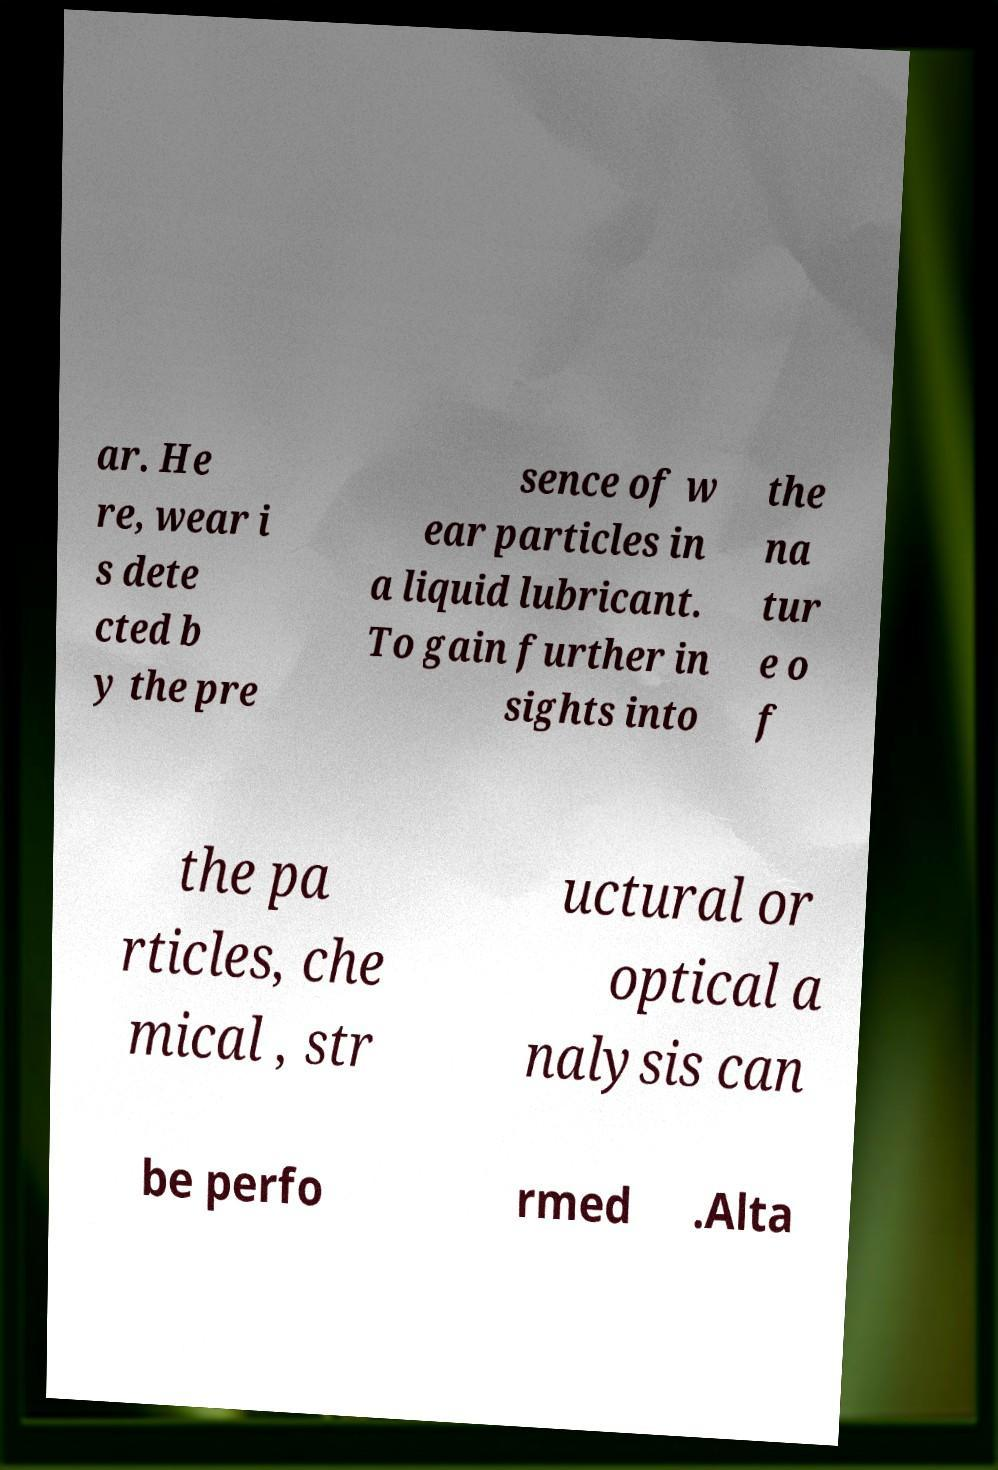Can you accurately transcribe the text from the provided image for me? ar. He re, wear i s dete cted b y the pre sence of w ear particles in a liquid lubricant. To gain further in sights into the na tur e o f the pa rticles, che mical , str uctural or optical a nalysis can be perfo rmed .Alta 